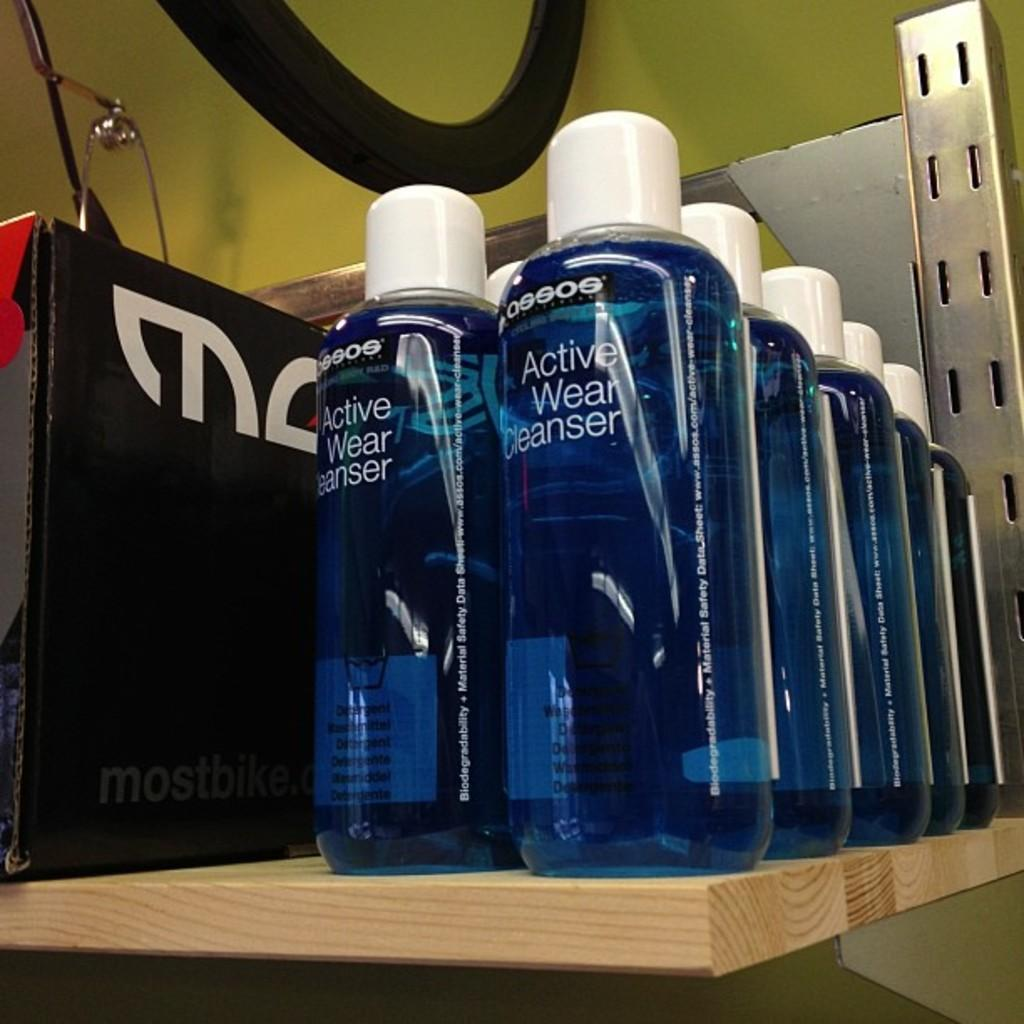How many rows of cleanser bottles are visible in the image? There are two rows of cleanser bottles visible in the image. Where are the cleanser bottles located? The cleanser bottles are placed on a shelf. What type of horse is standing next to the shelf in the image? There is no horse present in the image; it only features two rows of cleanser bottles on a shelf. 